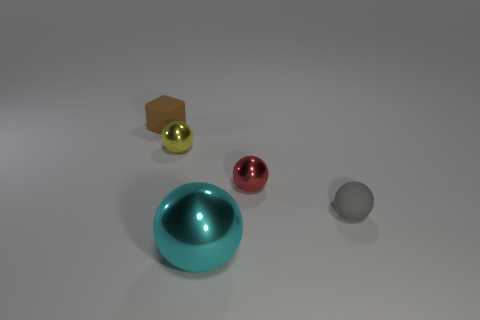There is a thing that is on the left side of the metallic thing left of the cyan thing; what number of matte blocks are in front of it?
Make the answer very short. 0. What number of spheres are either yellow metal objects or cyan objects?
Offer a terse response. 2. What color is the rubber thing to the right of the matte object behind the small rubber thing that is in front of the brown object?
Provide a short and direct response. Gray. What number of other things are the same size as the gray sphere?
Your answer should be compact. 3. Is there anything else that is the same shape as the large cyan metal object?
Ensure brevity in your answer.  Yes. The rubber thing that is the same shape as the large cyan shiny object is what color?
Make the answer very short. Gray. The small cube that is the same material as the gray thing is what color?
Make the answer very short. Brown. Are there an equal number of tiny blocks in front of the yellow sphere and tiny blue rubber cylinders?
Your response must be concise. Yes. There is a matte thing behind the gray ball; is its size the same as the large metal ball?
Provide a short and direct response. No. What color is the rubber block that is the same size as the gray thing?
Offer a very short reply. Brown. 